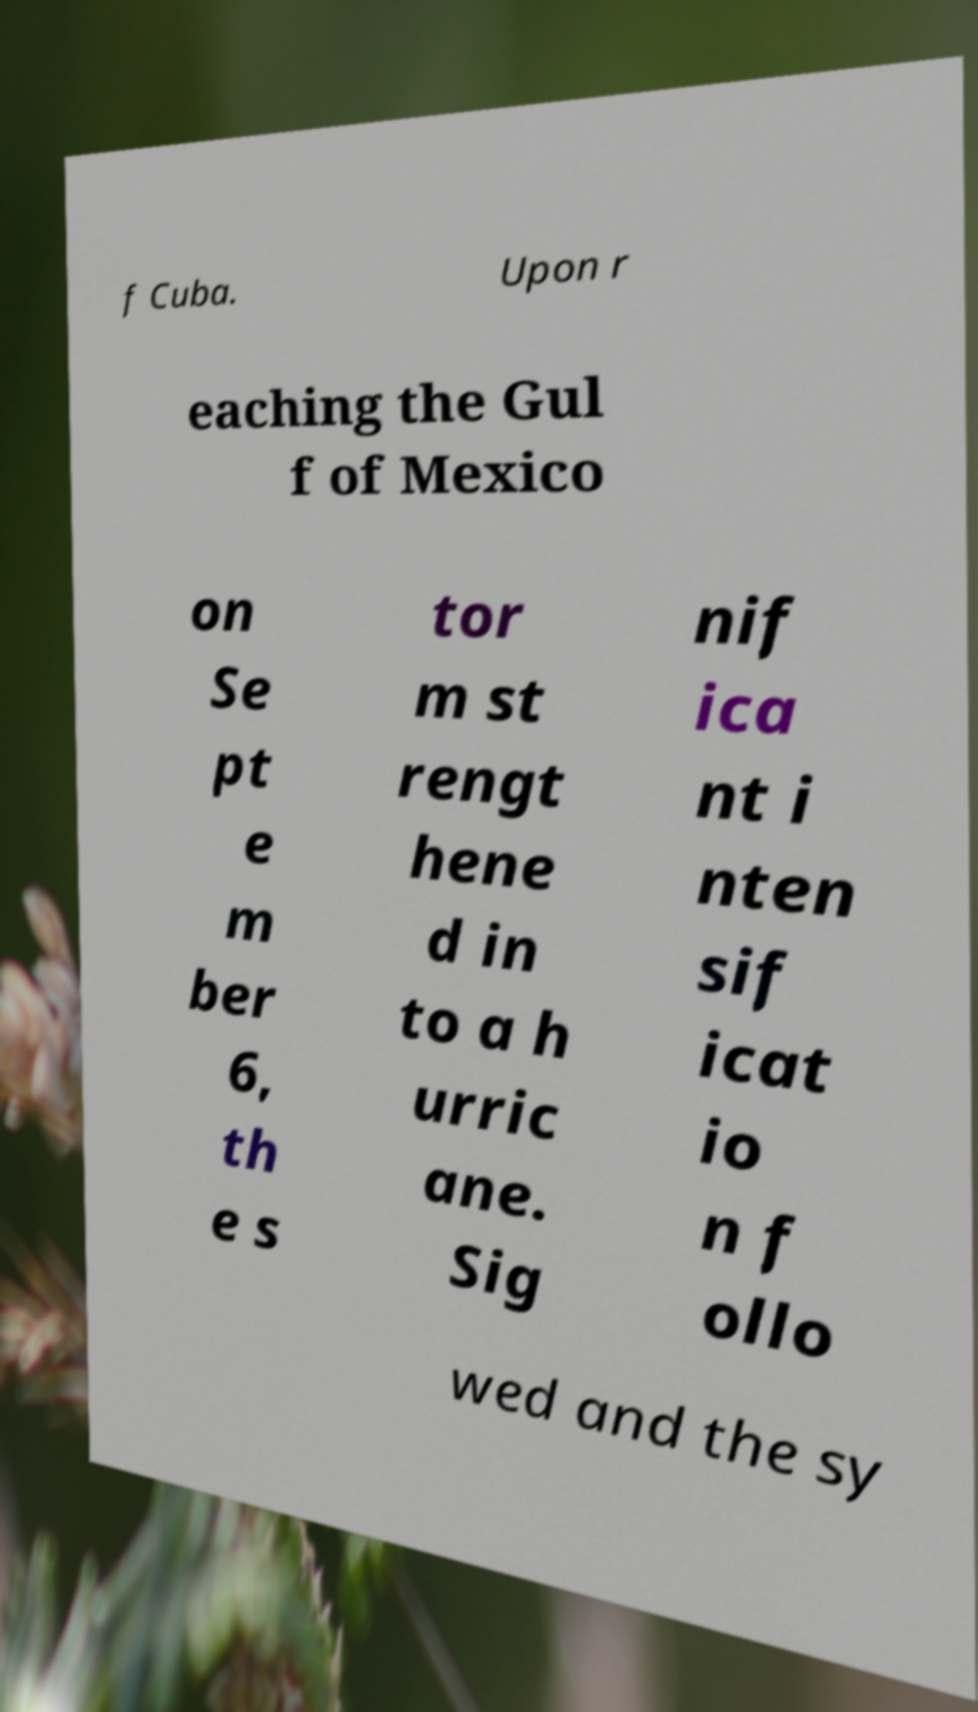What messages or text are displayed in this image? I need them in a readable, typed format. f Cuba. Upon r eaching the Gul f of Mexico on Se pt e m ber 6, th e s tor m st rengt hene d in to a h urric ane. Sig nif ica nt i nten sif icat io n f ollo wed and the sy 